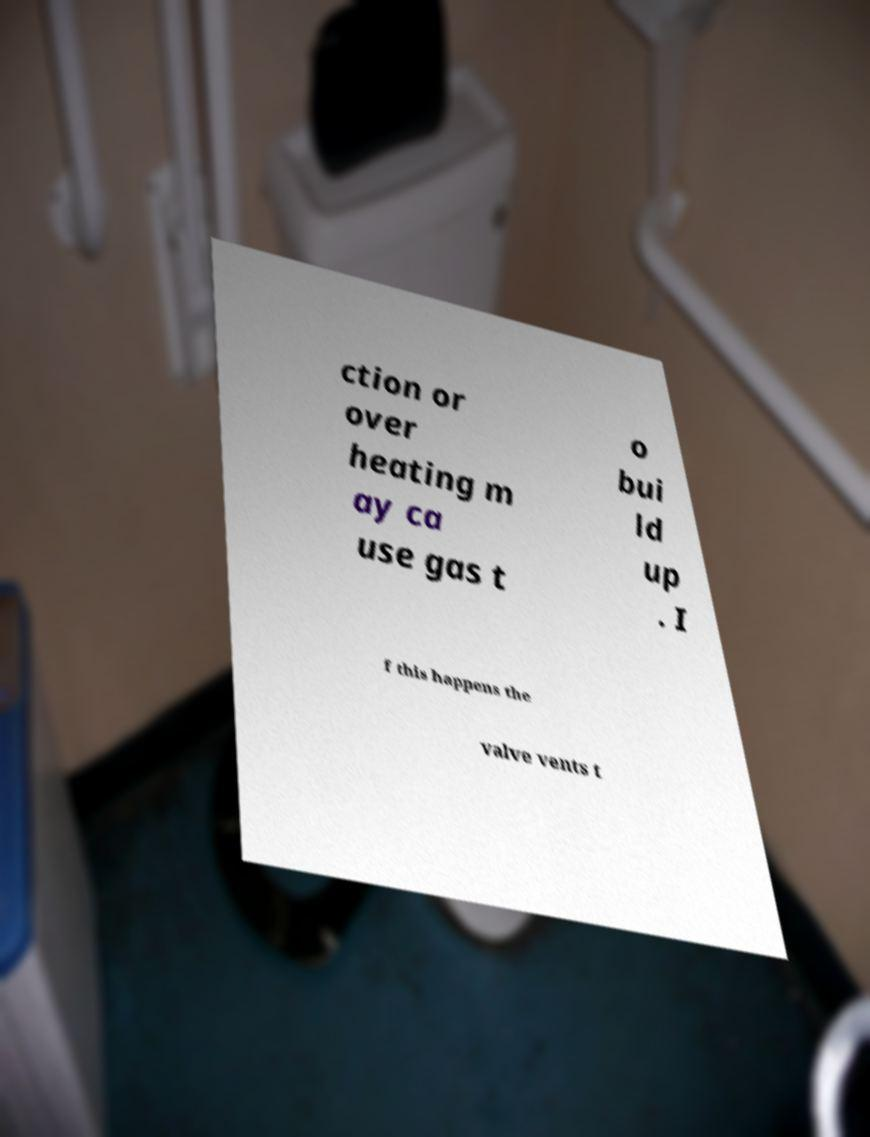I need the written content from this picture converted into text. Can you do that? ction or over heating m ay ca use gas t o bui ld up . I f this happens the valve vents t 